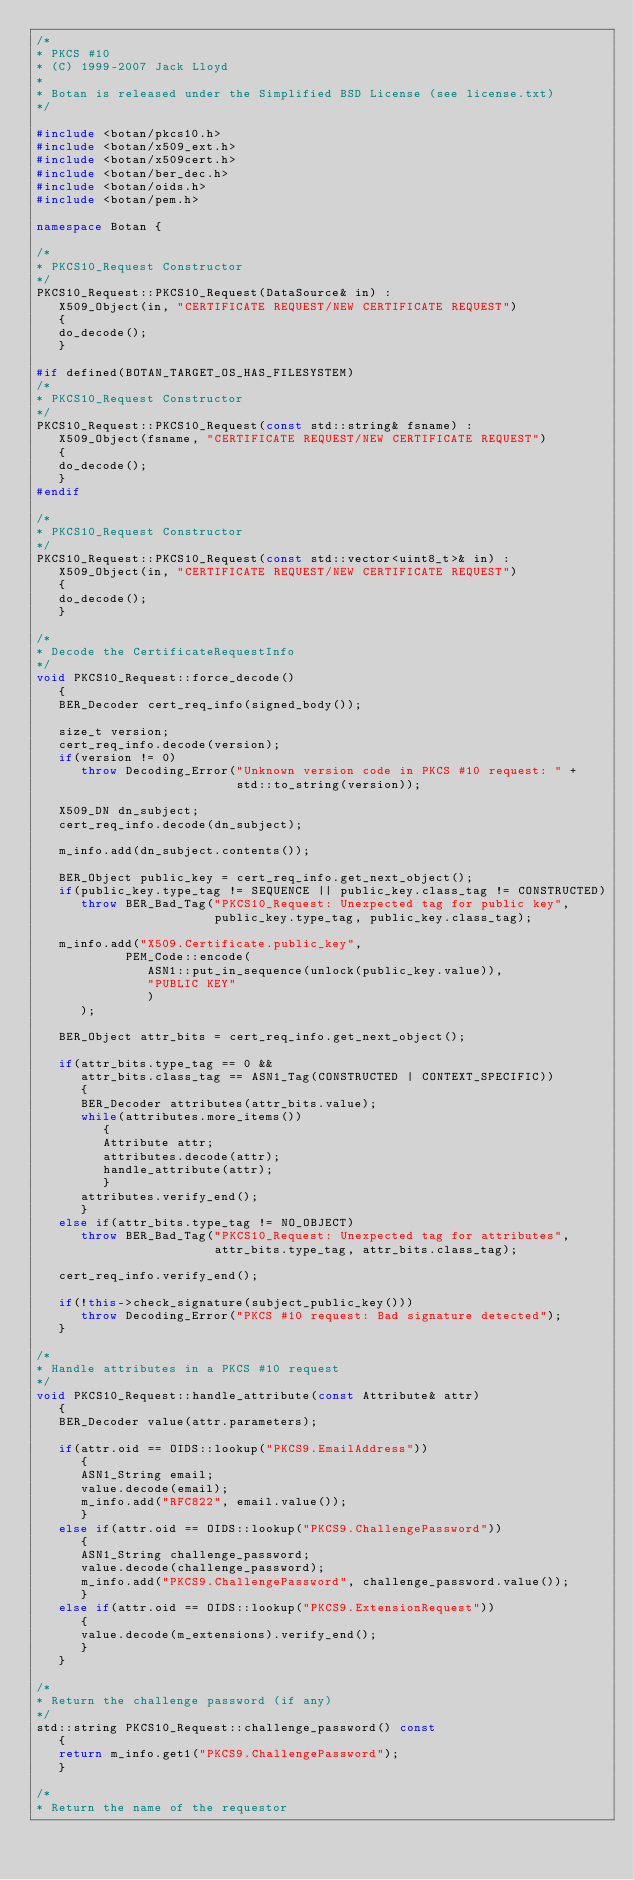Convert code to text. <code><loc_0><loc_0><loc_500><loc_500><_C++_>/*
* PKCS #10
* (C) 1999-2007 Jack Lloyd
*
* Botan is released under the Simplified BSD License (see license.txt)
*/

#include <botan/pkcs10.h>
#include <botan/x509_ext.h>
#include <botan/x509cert.h>
#include <botan/ber_dec.h>
#include <botan/oids.h>
#include <botan/pem.h>

namespace Botan {

/*
* PKCS10_Request Constructor
*/
PKCS10_Request::PKCS10_Request(DataSource& in) :
   X509_Object(in, "CERTIFICATE REQUEST/NEW CERTIFICATE REQUEST")
   {
   do_decode();
   }

#if defined(BOTAN_TARGET_OS_HAS_FILESYSTEM)
/*
* PKCS10_Request Constructor
*/
PKCS10_Request::PKCS10_Request(const std::string& fsname) :
   X509_Object(fsname, "CERTIFICATE REQUEST/NEW CERTIFICATE REQUEST")
   {
   do_decode();
   }
#endif

/*
* PKCS10_Request Constructor
*/
PKCS10_Request::PKCS10_Request(const std::vector<uint8_t>& in) :
   X509_Object(in, "CERTIFICATE REQUEST/NEW CERTIFICATE REQUEST")
   {
   do_decode();
   }

/*
* Decode the CertificateRequestInfo
*/
void PKCS10_Request::force_decode()
   {
   BER_Decoder cert_req_info(signed_body());

   size_t version;
   cert_req_info.decode(version);
   if(version != 0)
      throw Decoding_Error("Unknown version code in PKCS #10 request: " +
                           std::to_string(version));

   X509_DN dn_subject;
   cert_req_info.decode(dn_subject);

   m_info.add(dn_subject.contents());

   BER_Object public_key = cert_req_info.get_next_object();
   if(public_key.type_tag != SEQUENCE || public_key.class_tag != CONSTRUCTED)
      throw BER_Bad_Tag("PKCS10_Request: Unexpected tag for public key",
                        public_key.type_tag, public_key.class_tag);

   m_info.add("X509.Certificate.public_key",
            PEM_Code::encode(
               ASN1::put_in_sequence(unlock(public_key.value)),
               "PUBLIC KEY"
               )
      );

   BER_Object attr_bits = cert_req_info.get_next_object();

   if(attr_bits.type_tag == 0 &&
      attr_bits.class_tag == ASN1_Tag(CONSTRUCTED | CONTEXT_SPECIFIC))
      {
      BER_Decoder attributes(attr_bits.value);
      while(attributes.more_items())
         {
         Attribute attr;
         attributes.decode(attr);
         handle_attribute(attr);
         }
      attributes.verify_end();
      }
   else if(attr_bits.type_tag != NO_OBJECT)
      throw BER_Bad_Tag("PKCS10_Request: Unexpected tag for attributes",
                        attr_bits.type_tag, attr_bits.class_tag);

   cert_req_info.verify_end();

   if(!this->check_signature(subject_public_key()))
      throw Decoding_Error("PKCS #10 request: Bad signature detected");
   }

/*
* Handle attributes in a PKCS #10 request
*/
void PKCS10_Request::handle_attribute(const Attribute& attr)
   {
   BER_Decoder value(attr.parameters);

   if(attr.oid == OIDS::lookup("PKCS9.EmailAddress"))
      {
      ASN1_String email;
      value.decode(email);
      m_info.add("RFC822", email.value());
      }
   else if(attr.oid == OIDS::lookup("PKCS9.ChallengePassword"))
      {
      ASN1_String challenge_password;
      value.decode(challenge_password);
      m_info.add("PKCS9.ChallengePassword", challenge_password.value());
      }
   else if(attr.oid == OIDS::lookup("PKCS9.ExtensionRequest"))
      {
      value.decode(m_extensions).verify_end();
      }
   }

/*
* Return the challenge password (if any)
*/
std::string PKCS10_Request::challenge_password() const
   {
   return m_info.get1("PKCS9.ChallengePassword");
   }

/*
* Return the name of the requestor</code> 